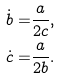Convert formula to latex. <formula><loc_0><loc_0><loc_500><loc_500>\dot { b } = & \frac { a } { 2 c } , \\ \dot { c } = & \frac { a } { 2 b } .</formula> 